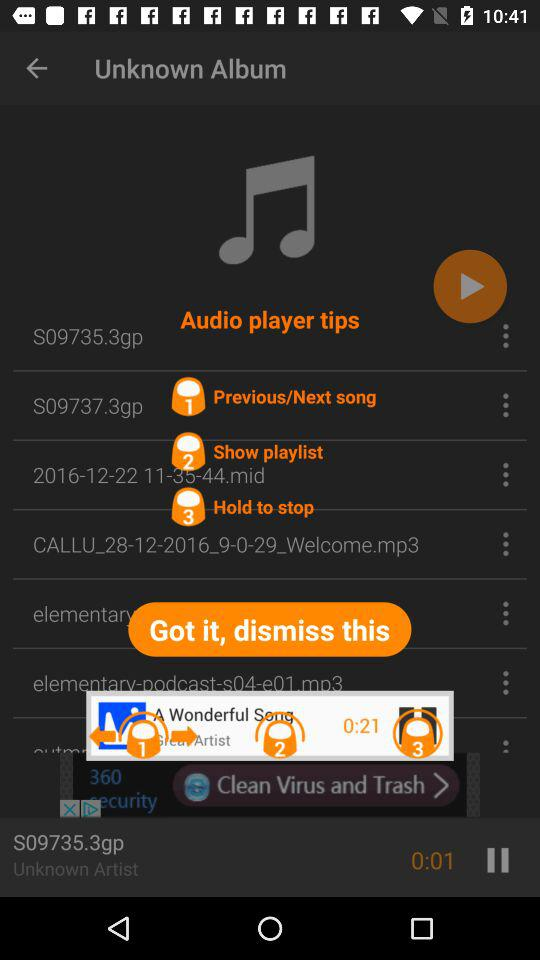What is the 1st tip of the audio player? The 1st tip of the audio player is previous/next song. 